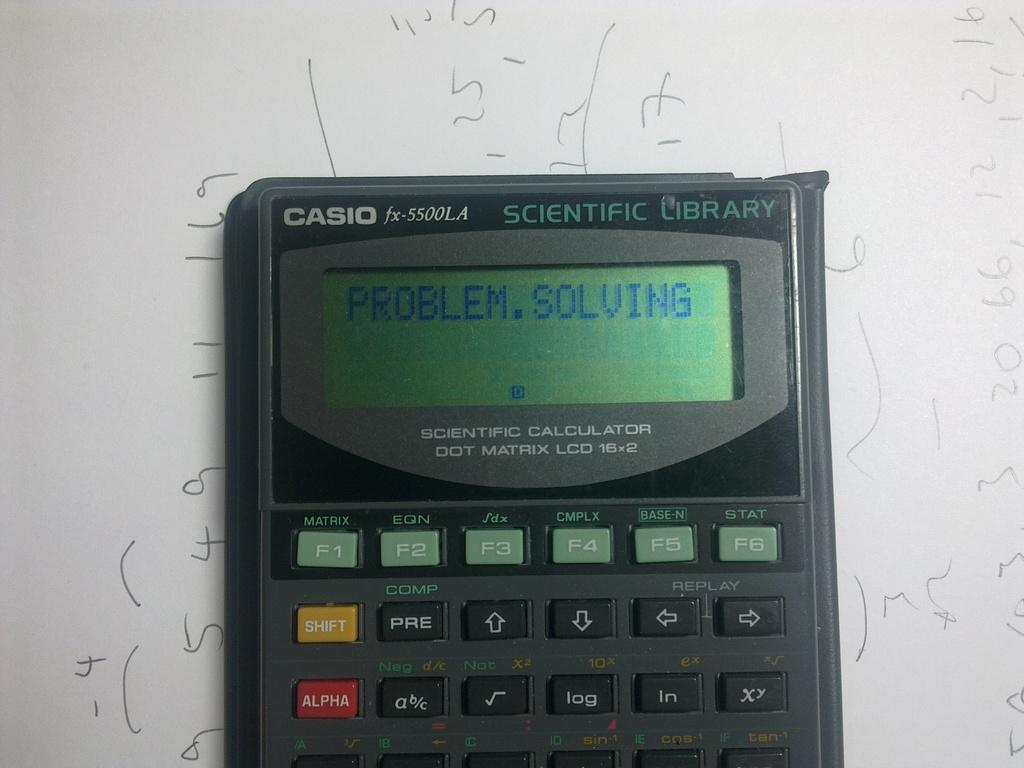What is the calculator brand?
Your answer should be very brief. Casio. What is the calculator solving?
Provide a short and direct response. Problem. 